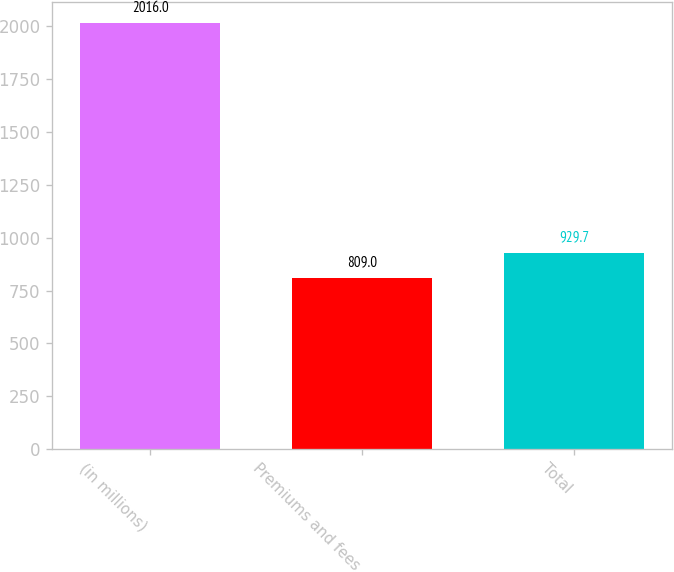<chart> <loc_0><loc_0><loc_500><loc_500><bar_chart><fcel>(in millions)<fcel>Premiums and fees<fcel>Total<nl><fcel>2016<fcel>809<fcel>929.7<nl></chart> 